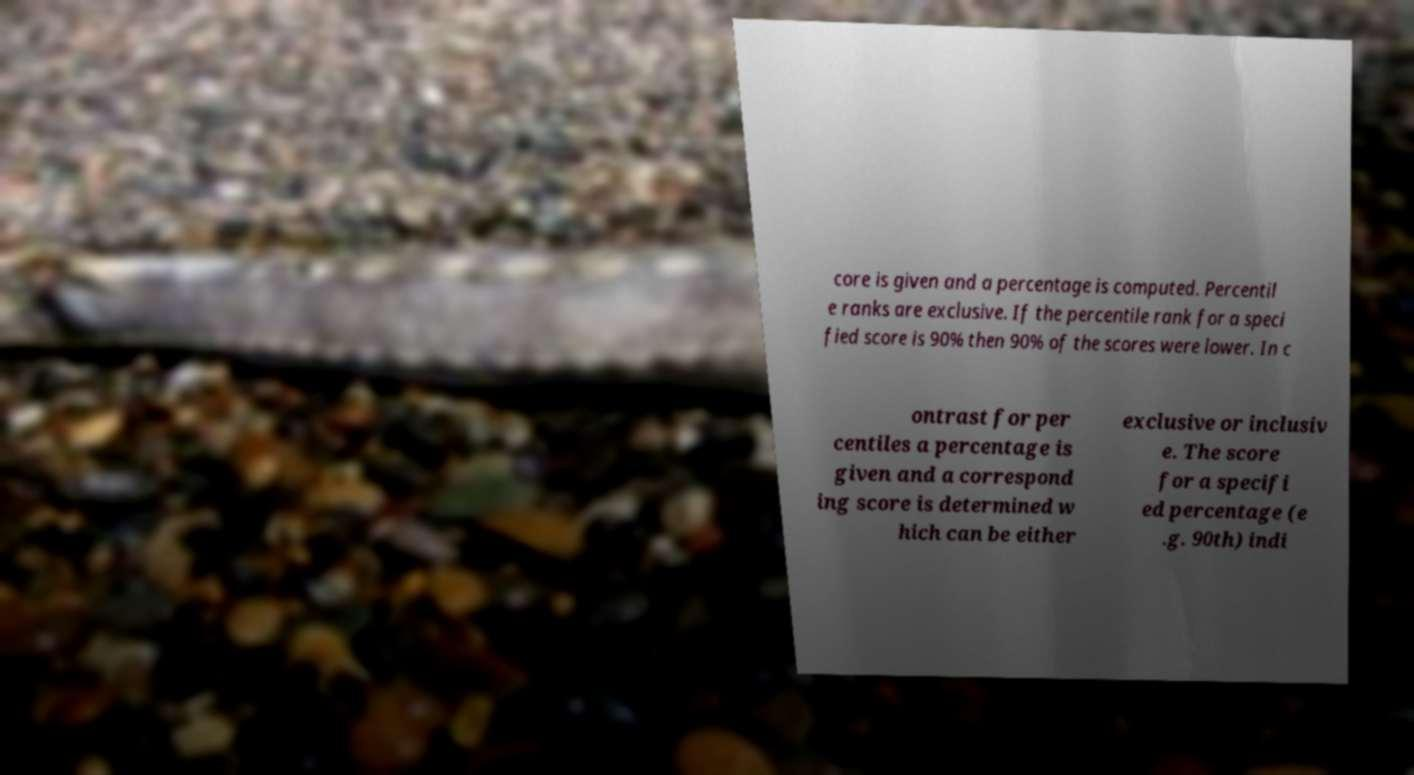There's text embedded in this image that I need extracted. Can you transcribe it verbatim? core is given and a percentage is computed. Percentil e ranks are exclusive. If the percentile rank for a speci fied score is 90% then 90% of the scores were lower. In c ontrast for per centiles a percentage is given and a correspond ing score is determined w hich can be either exclusive or inclusiv e. The score for a specifi ed percentage (e .g. 90th) indi 